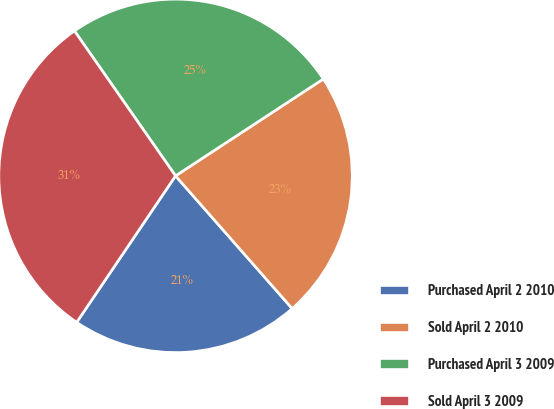Convert chart to OTSL. <chart><loc_0><loc_0><loc_500><loc_500><pie_chart><fcel>Purchased April 2 2010<fcel>Sold April 2 2010<fcel>Purchased April 3 2009<fcel>Sold April 3 2009<nl><fcel>20.93%<fcel>22.76%<fcel>25.46%<fcel>30.86%<nl></chart> 